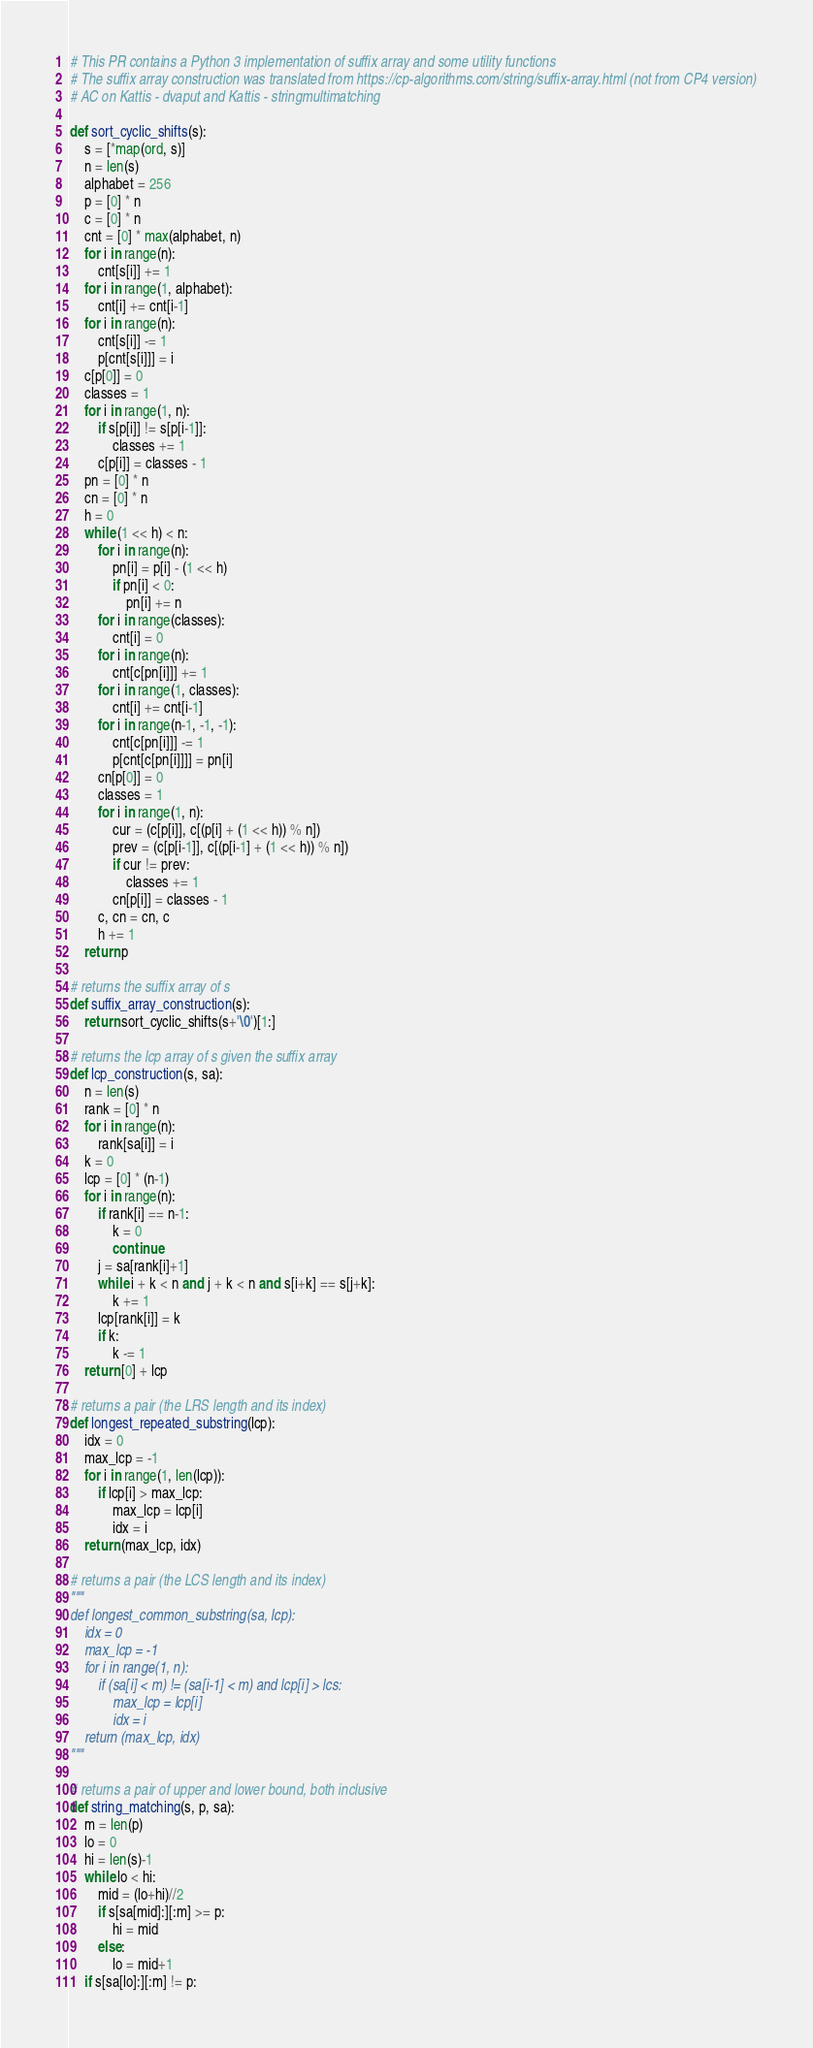Convert code to text. <code><loc_0><loc_0><loc_500><loc_500><_Cython_># This PR contains a Python 3 implementation of suffix array and some utility functions
# The suffix array construction was translated from https://cp-algorithms.com/string/suffix-array.html (not from CP4 version)
# AC on Kattis - dvaput and Kattis - stringmultimatching

def sort_cyclic_shifts(s):
    s = [*map(ord, s)]
    n = len(s)
    alphabet = 256
    p = [0] * n
    c = [0] * n
    cnt = [0] * max(alphabet, n)
    for i in range(n):
        cnt[s[i]] += 1
    for i in range(1, alphabet):
        cnt[i] += cnt[i-1]
    for i in range(n):
        cnt[s[i]] -= 1
        p[cnt[s[i]]] = i
    c[p[0]] = 0
    classes = 1
    for i in range(1, n):
        if s[p[i]] != s[p[i-1]]:
            classes += 1
        c[p[i]] = classes - 1
    pn = [0] * n
    cn = [0] * n
    h = 0
    while (1 << h) < n:
        for i in range(n):
            pn[i] = p[i] - (1 << h)
            if pn[i] < 0:
                pn[i] += n
        for i in range(classes):
            cnt[i] = 0
        for i in range(n):
            cnt[c[pn[i]]] += 1
        for i in range(1, classes):
            cnt[i] += cnt[i-1]
        for i in range(n-1, -1, -1):
            cnt[c[pn[i]]] -= 1
            p[cnt[c[pn[i]]]] = pn[i]
        cn[p[0]] = 0
        classes = 1
        for i in range(1, n):
            cur = (c[p[i]], c[(p[i] + (1 << h)) % n])
            prev = (c[p[i-1]], c[(p[i-1] + (1 << h)) % n])
            if cur != prev:
                classes += 1
            cn[p[i]] = classes - 1
        c, cn = cn, c
        h += 1
    return p

# returns the suffix array of s
def suffix_array_construction(s):
    return sort_cyclic_shifts(s+'\0')[1:]

# returns the lcp array of s given the suffix array
def lcp_construction(s, sa):
    n = len(s)
    rank = [0] * n
    for i in range(n):
        rank[sa[i]] = i
    k = 0
    lcp = [0] * (n-1)
    for i in range(n):
        if rank[i] == n-1:
            k = 0
            continue
        j = sa[rank[i]+1]
        while i + k < n and j + k < n and s[i+k] == s[j+k]:
            k += 1
        lcp[rank[i]] = k
        if k:
            k -= 1
    return [0] + lcp

# returns a pair (the LRS length and its index)
def longest_repeated_substring(lcp):
    idx = 0
    max_lcp = -1
    for i in range(1, len(lcp)):
        if lcp[i] > max_lcp:
            max_lcp = lcp[i]
            idx = i
    return (max_lcp, idx)

# returns a pair (the LCS length and its index)
"""
def longest_common_substring(sa, lcp):
    idx = 0
    max_lcp = -1
    for i in range(1, n):
        if (sa[i] < m) != (sa[i-1] < m) and lcp[i] > lcs:
            max_lcp = lcp[i]
            idx = i
    return (max_lcp, idx)
"""

# returns a pair of upper and lower bound, both inclusive
def string_matching(s, p, sa):
    m = len(p)
    lo = 0
    hi = len(s)-1
    while lo < hi:
        mid = (lo+hi)//2
        if s[sa[mid]:][:m] >= p:
            hi = mid
        else:
            lo = mid+1
    if s[sa[lo]:][:m] != p:</code> 